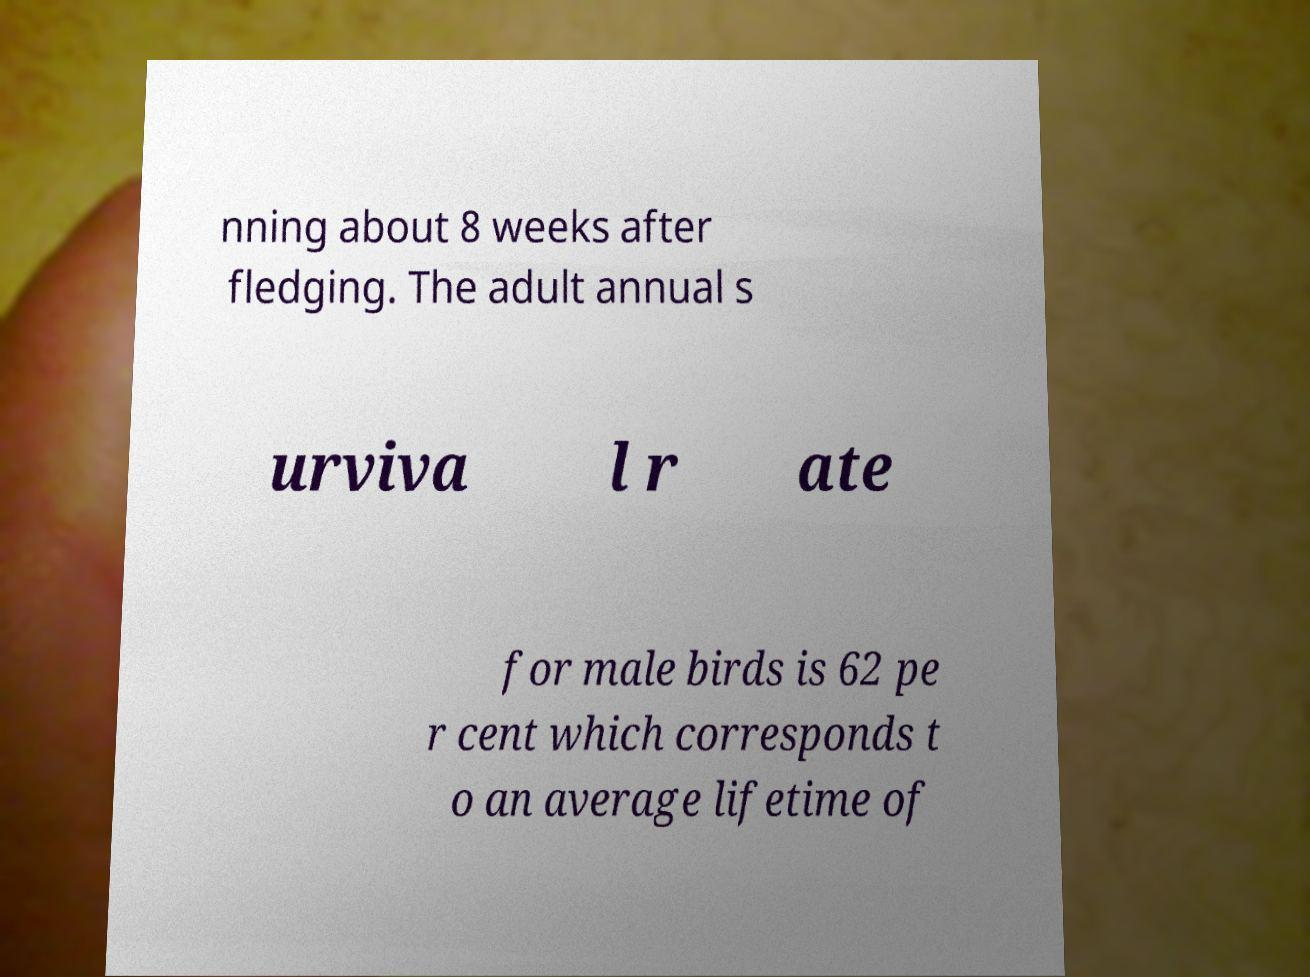There's text embedded in this image that I need extracted. Can you transcribe it verbatim? nning about 8 weeks after fledging. The adult annual s urviva l r ate for male birds is 62 pe r cent which corresponds t o an average lifetime of 